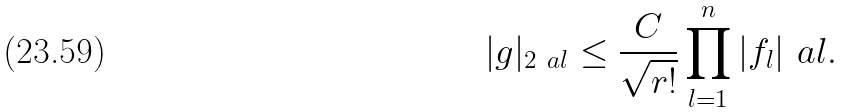Convert formula to latex. <formula><loc_0><loc_0><loc_500><loc_500>| g | _ { 2 \ a l } \leq \frac { C } { \sqrt { r ! } } \prod _ { l = 1 } ^ { n } | f _ { l } | _ { \ } a l .</formula> 